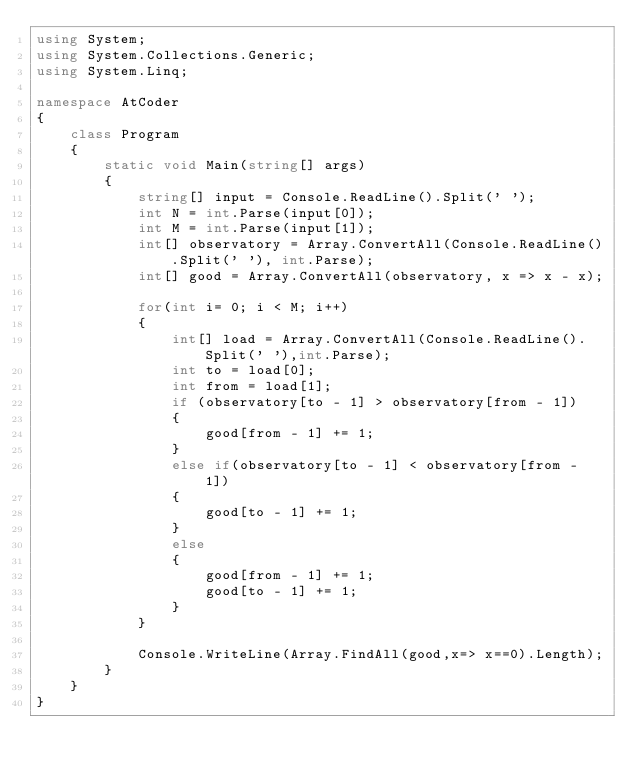Convert code to text. <code><loc_0><loc_0><loc_500><loc_500><_C#_>using System;
using System.Collections.Generic;
using System.Linq;

namespace AtCoder
{
    class Program
    {
        static void Main(string[] args)
        {
            string[] input = Console.ReadLine().Split(' ');
            int N = int.Parse(input[0]);
            int M = int.Parse(input[1]);
            int[] observatory = Array.ConvertAll(Console.ReadLine().Split(' '), int.Parse);
            int[] good = Array.ConvertAll(observatory, x => x - x);

            for(int i= 0; i < M; i++)
            {
                int[] load = Array.ConvertAll(Console.ReadLine().Split(' '),int.Parse);
                int to = load[0];
                int from = load[1];
                if (observatory[to - 1] > observatory[from - 1])
                {
                    good[from - 1] += 1;
                }
                else if(observatory[to - 1] < observatory[from - 1])
                {
                    good[to - 1] += 1;
                }
                else
                {
                    good[from - 1] += 1;
                    good[to - 1] += 1;
                }
            }

            Console.WriteLine(Array.FindAll(good,x=> x==0).Length);
        }
    }
}
</code> 